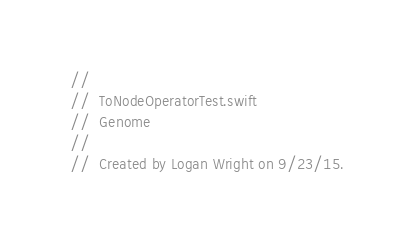<code> <loc_0><loc_0><loc_500><loc_500><_Swift_>//
//  ToNodeOperatorTest.swift
//  Genome
//
//  Created by Logan Wright on 9/23/15.</code> 